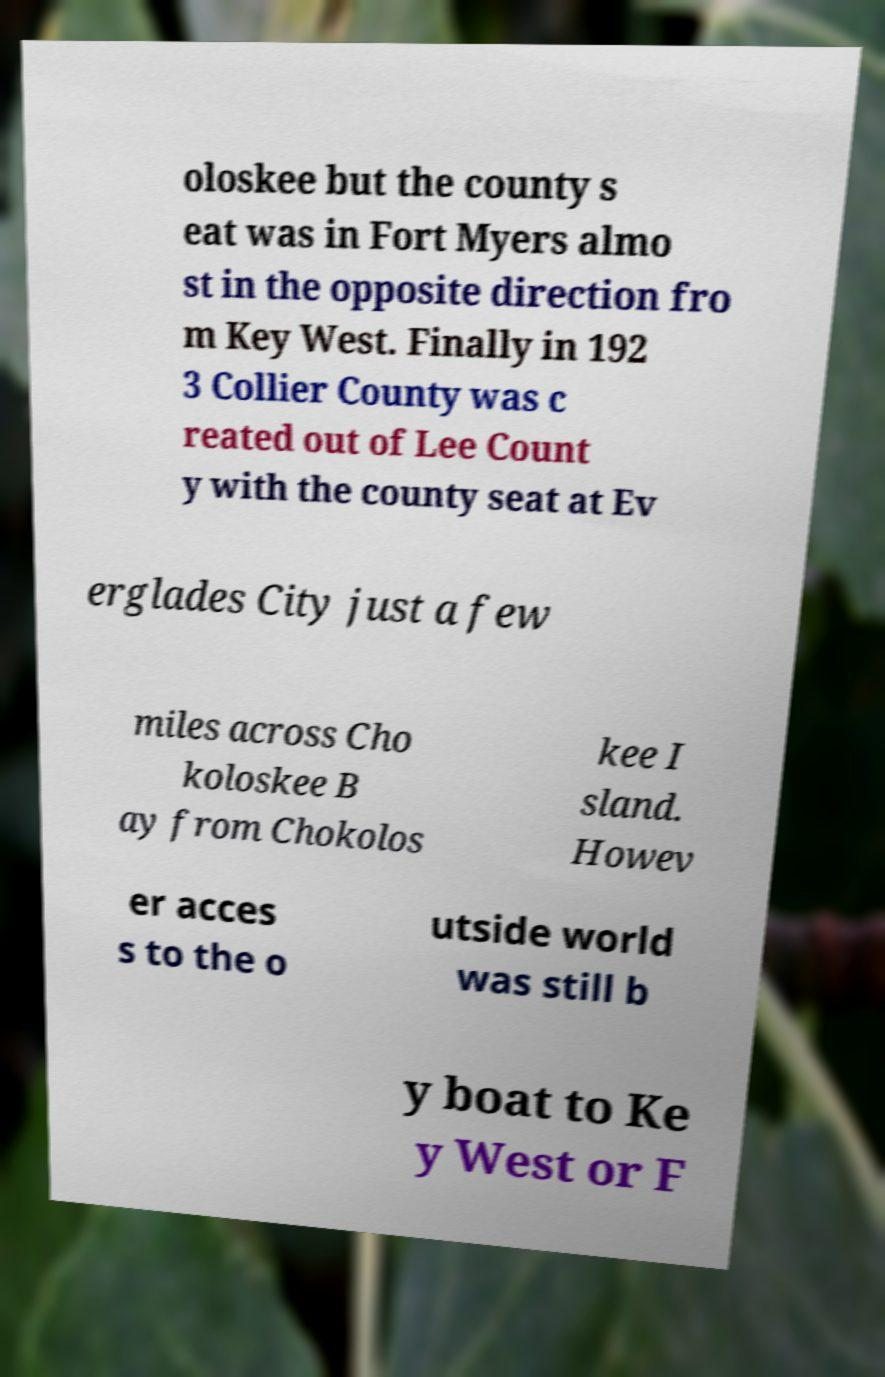Please read and relay the text visible in this image. What does it say? oloskee but the county s eat was in Fort Myers almo st in the opposite direction fro m Key West. Finally in 192 3 Collier County was c reated out of Lee Count y with the county seat at Ev erglades City just a few miles across Cho koloskee B ay from Chokolos kee I sland. Howev er acces s to the o utside world was still b y boat to Ke y West or F 